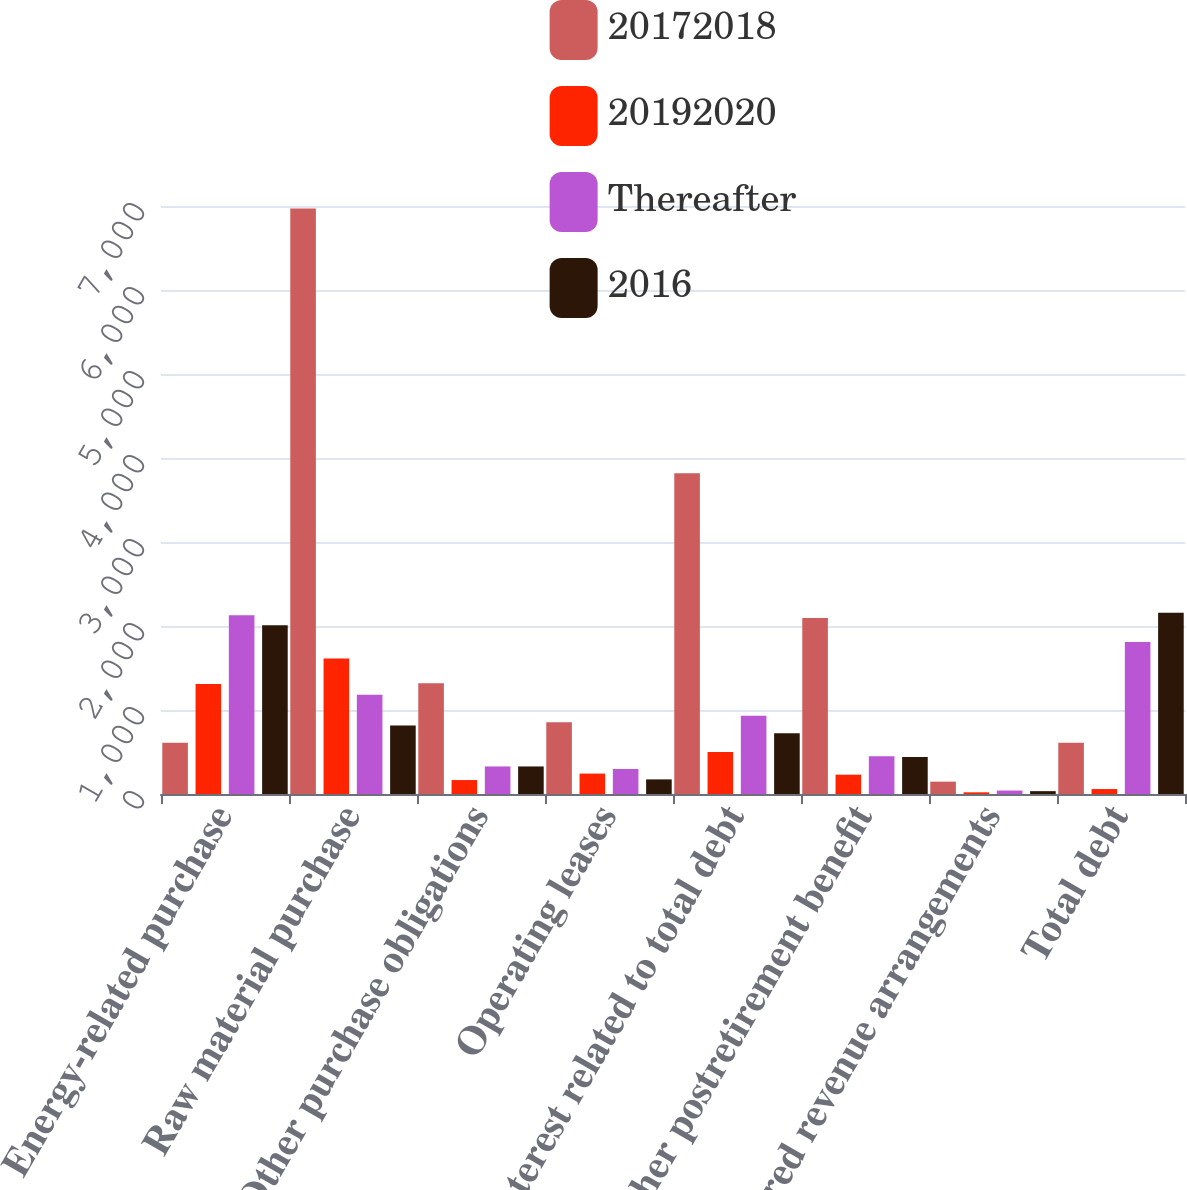<chart> <loc_0><loc_0><loc_500><loc_500><stacked_bar_chart><ecel><fcel>Energy-related purchase<fcel>Raw material purchase<fcel>Other purchase obligations<fcel>Operating leases<fcel>Interest related to total debt<fcel>Other postretirement benefit<fcel>Deferred revenue arrangements<fcel>Total debt<nl><fcel>20172018<fcel>611.5<fcel>6970<fcel>1317<fcel>853<fcel>3817<fcel>2095<fcel>147<fcel>611.5<nl><fcel>20192020<fcel>1311<fcel>1612<fcel>166<fcel>243<fcel>500<fcel>230<fcel>20<fcel>59<nl><fcel>Thereafter<fcel>2128<fcel>1183<fcel>328<fcel>298<fcel>933<fcel>450<fcel>41<fcel>1810<nl><fcel>2016<fcel>2009<fcel>815<fcel>328<fcel>174<fcel>723<fcel>440<fcel>34<fcel>2158<nl></chart> 